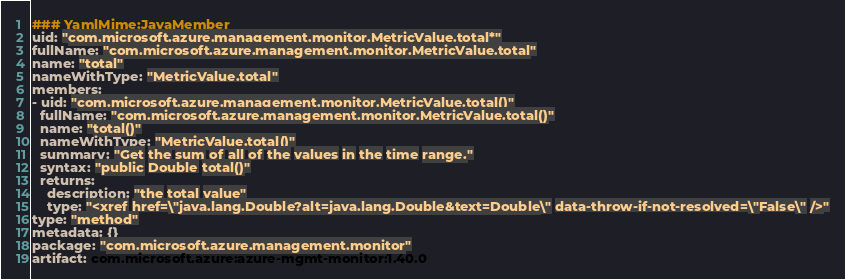<code> <loc_0><loc_0><loc_500><loc_500><_YAML_>### YamlMime:JavaMember
uid: "com.microsoft.azure.management.monitor.MetricValue.total*"
fullName: "com.microsoft.azure.management.monitor.MetricValue.total"
name: "total"
nameWithType: "MetricValue.total"
members:
- uid: "com.microsoft.azure.management.monitor.MetricValue.total()"
  fullName: "com.microsoft.azure.management.monitor.MetricValue.total()"
  name: "total()"
  nameWithType: "MetricValue.total()"
  summary: "Get the sum of all of the values in the time range."
  syntax: "public Double total()"
  returns:
    description: "the total value"
    type: "<xref href=\"java.lang.Double?alt=java.lang.Double&text=Double\" data-throw-if-not-resolved=\"False\" />"
type: "method"
metadata: {}
package: "com.microsoft.azure.management.monitor"
artifact: com.microsoft.azure:azure-mgmt-monitor:1.40.0
</code> 